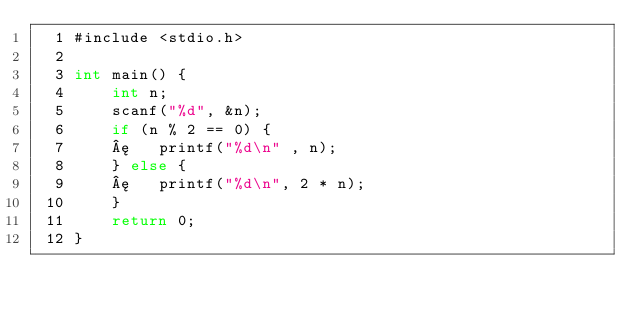Convert code to text. <code><loc_0><loc_0><loc_500><loc_500><_C_>  1 #include <stdio.h>
  2 
  3 int main() {
  4     int n;
  5     scanf("%d", &n);
  6     if (n % 2 == 0) {
  7     ¦   printf("%d\n" , n);
  8     } else {
  9     ¦   printf("%d\n", 2 * n);
 10     }
 11     return 0;
 12 }
</code> 